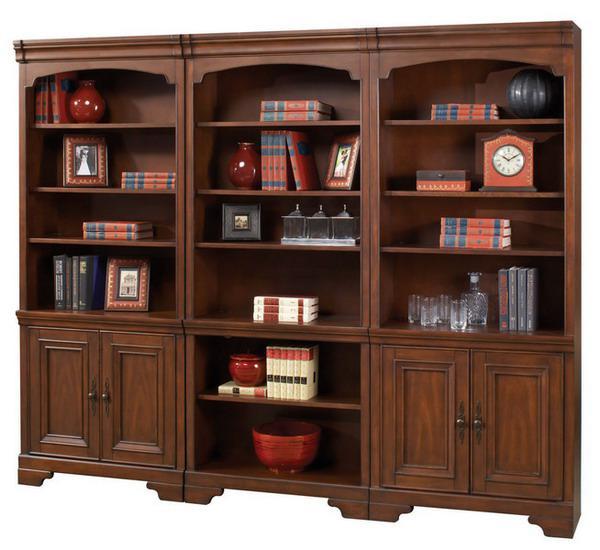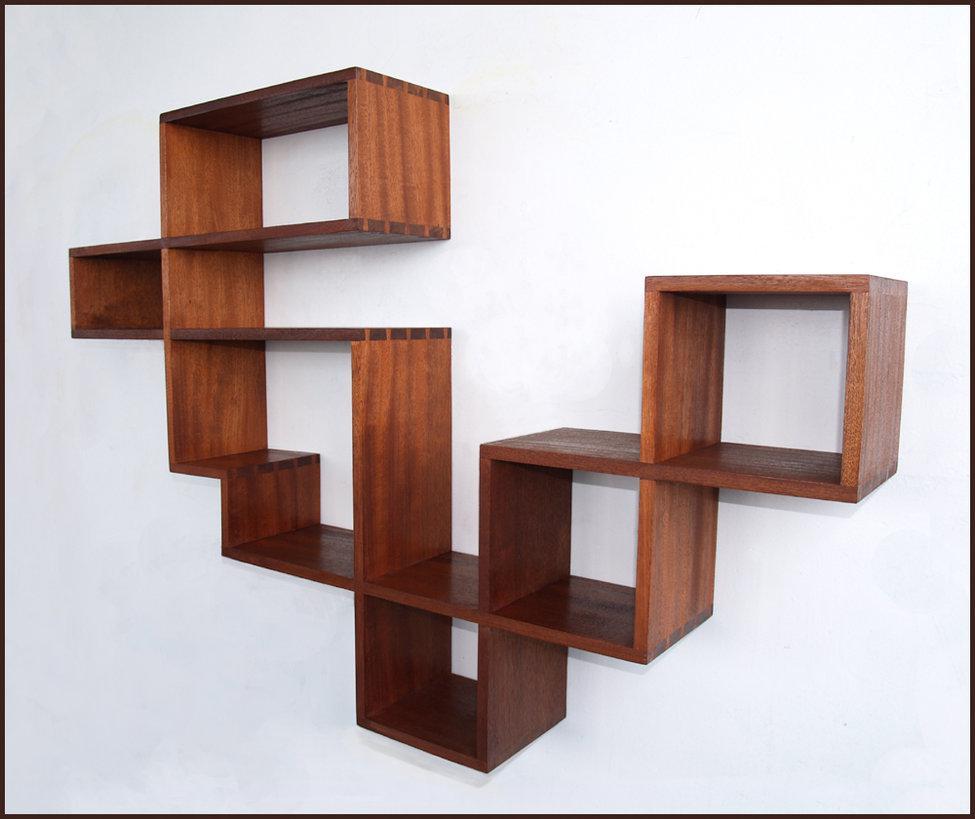The first image is the image on the left, the second image is the image on the right. Given the left and right images, does the statement "A shelving unit is attached to the wall." hold true? Answer yes or no. Yes. 